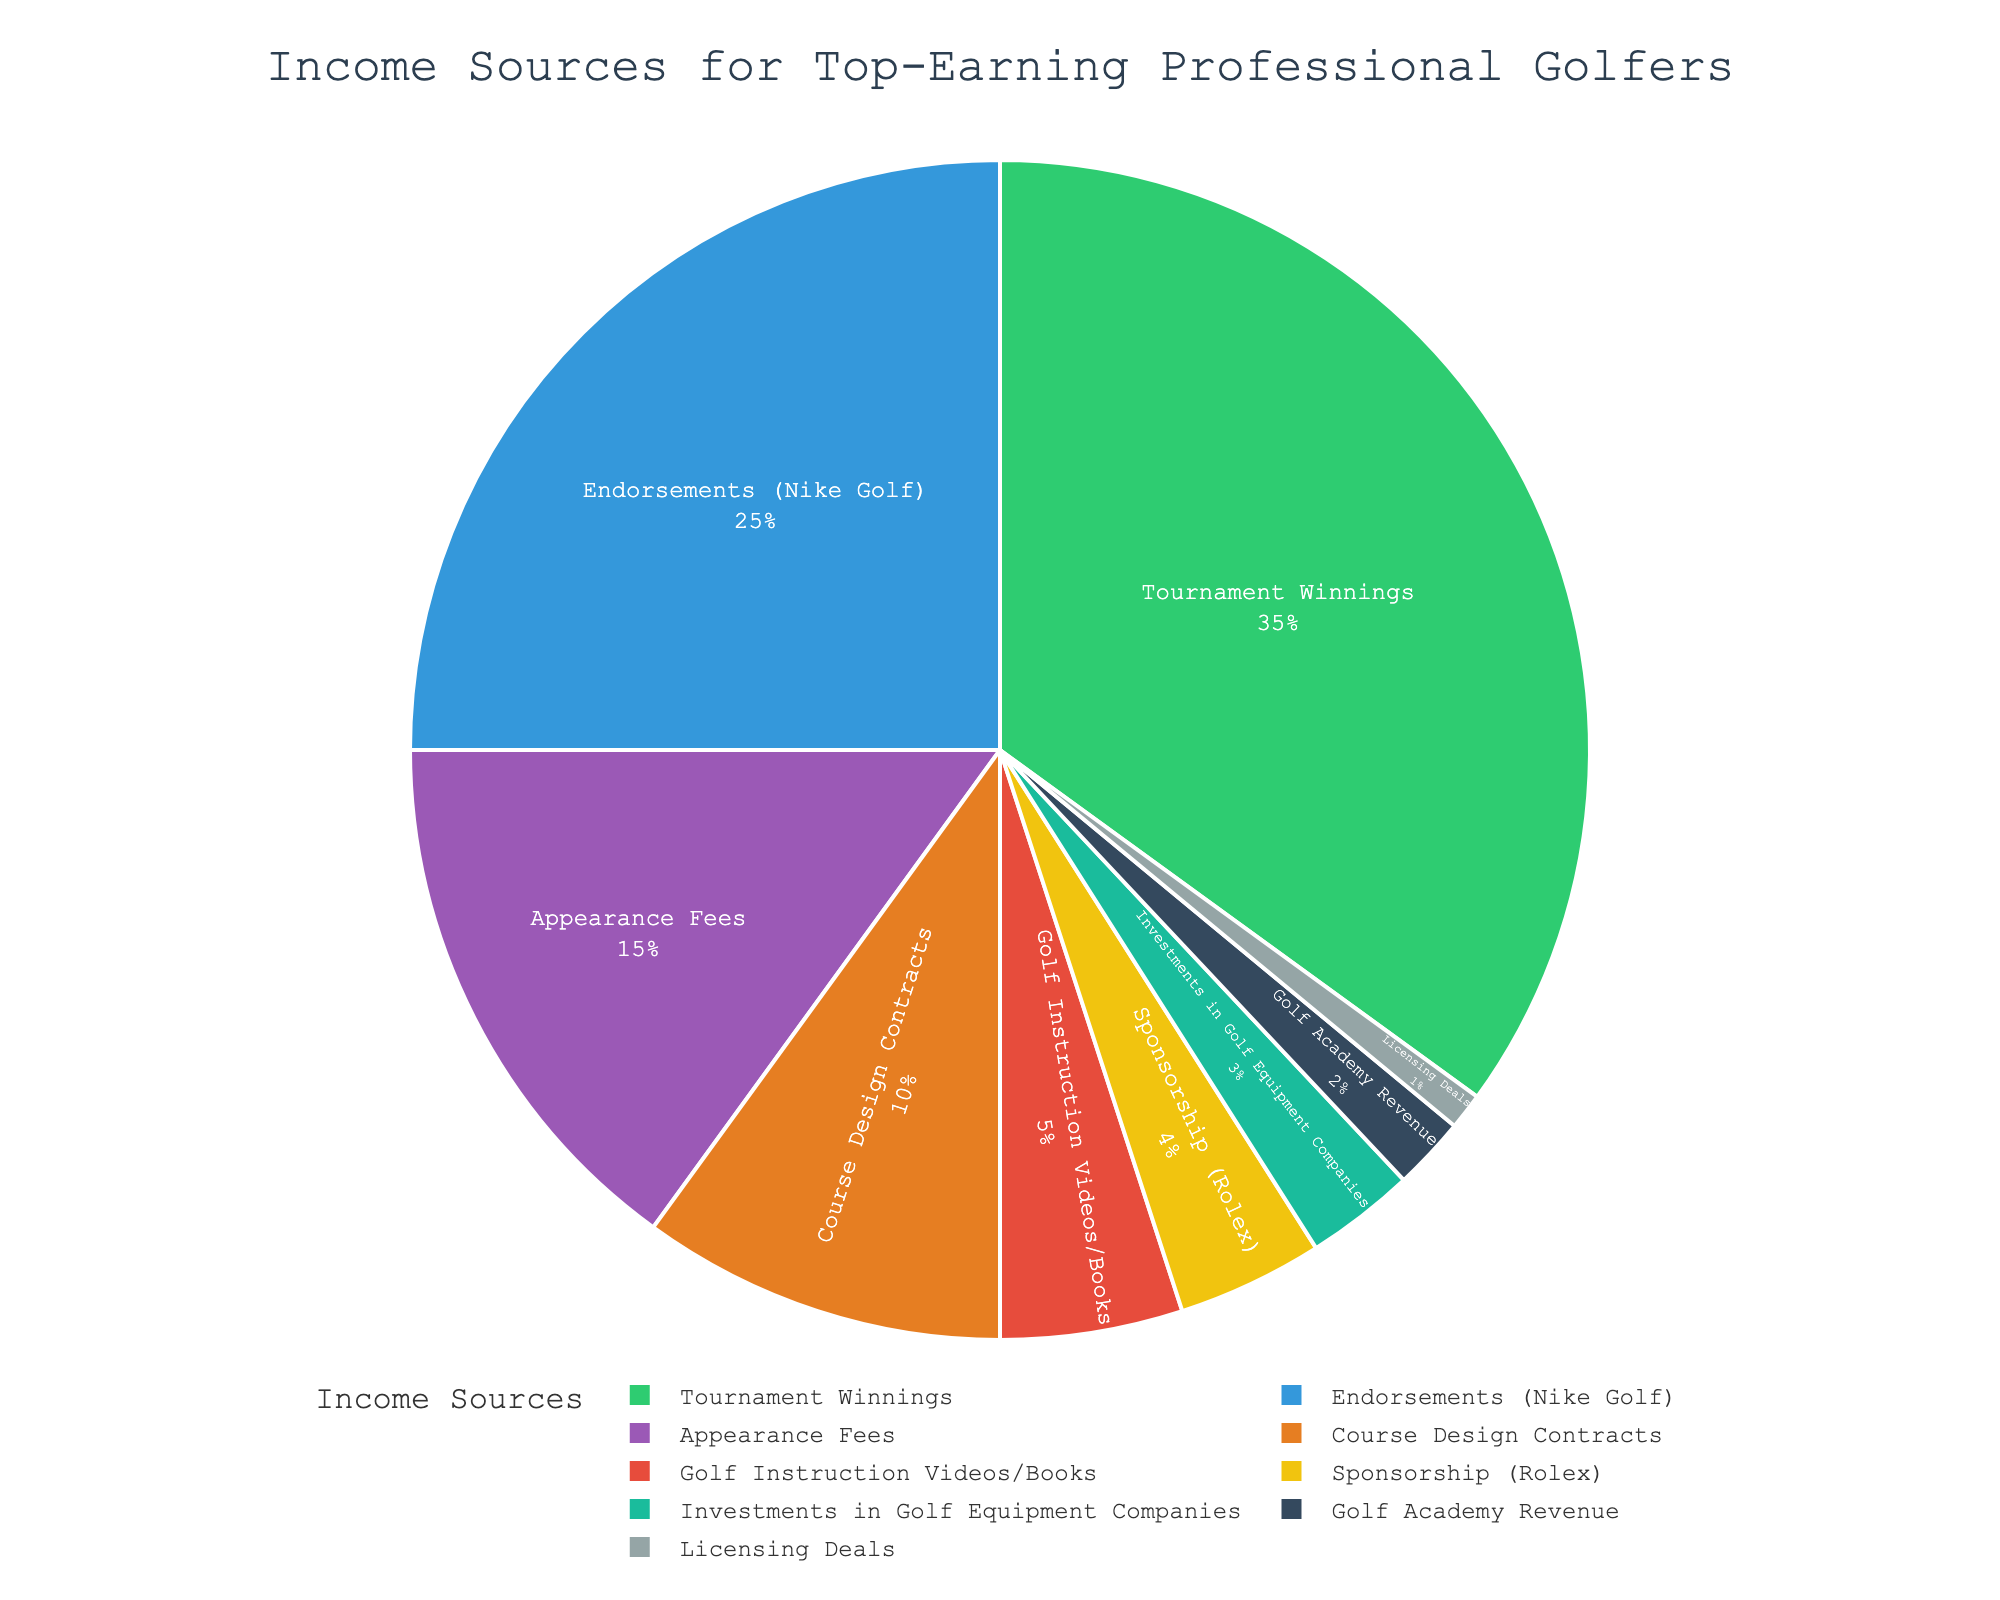What's the largest income source for top-earning professional golfers? The largest slice of the pie chart represents the biggest income source. By looking at the chart, "Tournament Winnings" is the largest.
Answer: Tournament Winnings Which two income sources together make up less than 5% of the total income? Adding up the percentages directly from the chart: "Licensing Deals" (1%) and "Golf Academy Revenue" (2%) add up to 3%, which is less than 5%.
Answer: Licensing Deals and Golf Academy Revenue How much more is earned from Endorsements (Nike Golf) than from Course Design Contracts? Endorsements (Nike Golf) account for 25%, and Course Design Contracts account for 10%. Subtracting these values gives 25% - 10% = 15%.
Answer: 15% What is the total percentage of income from Sponsorship (Rolex) and Investments in Golf Equipment Companies? Adding the percentages: Sponsorship (Rolex) is 4% and Investments in Golf Equipment Companies is 3%. Therefore, 4% + 3% = 7%.
Answer: 7% Which income source is depicted in green in the pie chart? The green slice represents "Tournament Winnings" based on its largest size and color.
Answer: Tournament Winnings Are Appearance Fees a larger income source than Golf Instruction Videos/Books? Comparing their slices, Appearance Fees are 15%, while Golf Instruction Videos/Books are 5%. Appearance Fees are larger.
Answer: Yes What is the second highest income source after Tournament Winnings? The pie chart shows the second-largest slice is for "Endorsements (Nike Golf)" at 25%.
Answer: Endorsements (Nike Golf) How much more does Course Design Contracts contribute compared to Golf Academy Revenue? Course Design Contracts account for 10% of the income, and Golf Academy Revenue accounts for 2%. Subtracting these values gives 10% - 2% = 8%.
Answer: 8% List all income sources that contribute less than 10% each. By examining the slices, the sources are: Course Design Contracts (10%), Golf Instruction Videos/Books (5%), Sponsorship (Rolex) (4%), Investments in Golf Equipment Companies (3%), Golf Academy Revenue (2%), and Licensing Deals (1%).
Answer: Course Design Contracts, Golf Instruction Videos/Books, Sponsorship (Rolex), Investments in Golf Equipment Companies, Golf Academy Revenue, Licensing Deals 